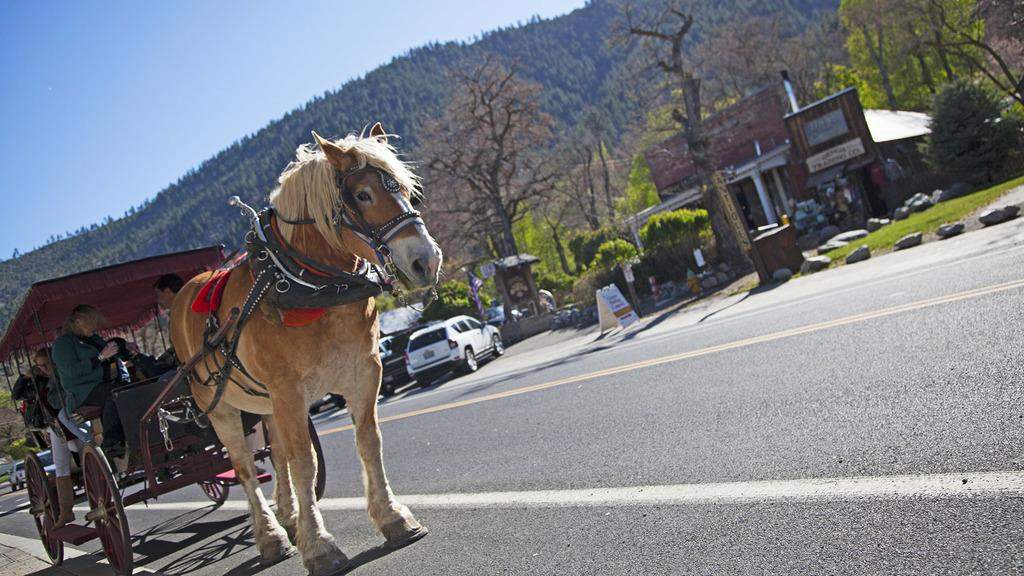What type of vehicle is in the image? There is a horse cart in the image. Who is inside the horse cart? There are people inside the horse cart. What can be seen in the background of the image? There are trees, a building, rocks, and the sky visible in the background of the image. What is the setting of the image? The image shows a road with vehicles, a horse cart, and people. What type of music is being played by the rocks in the background of the image? There is no music being played by the rocks in the image; they are simply rocks in the background. 